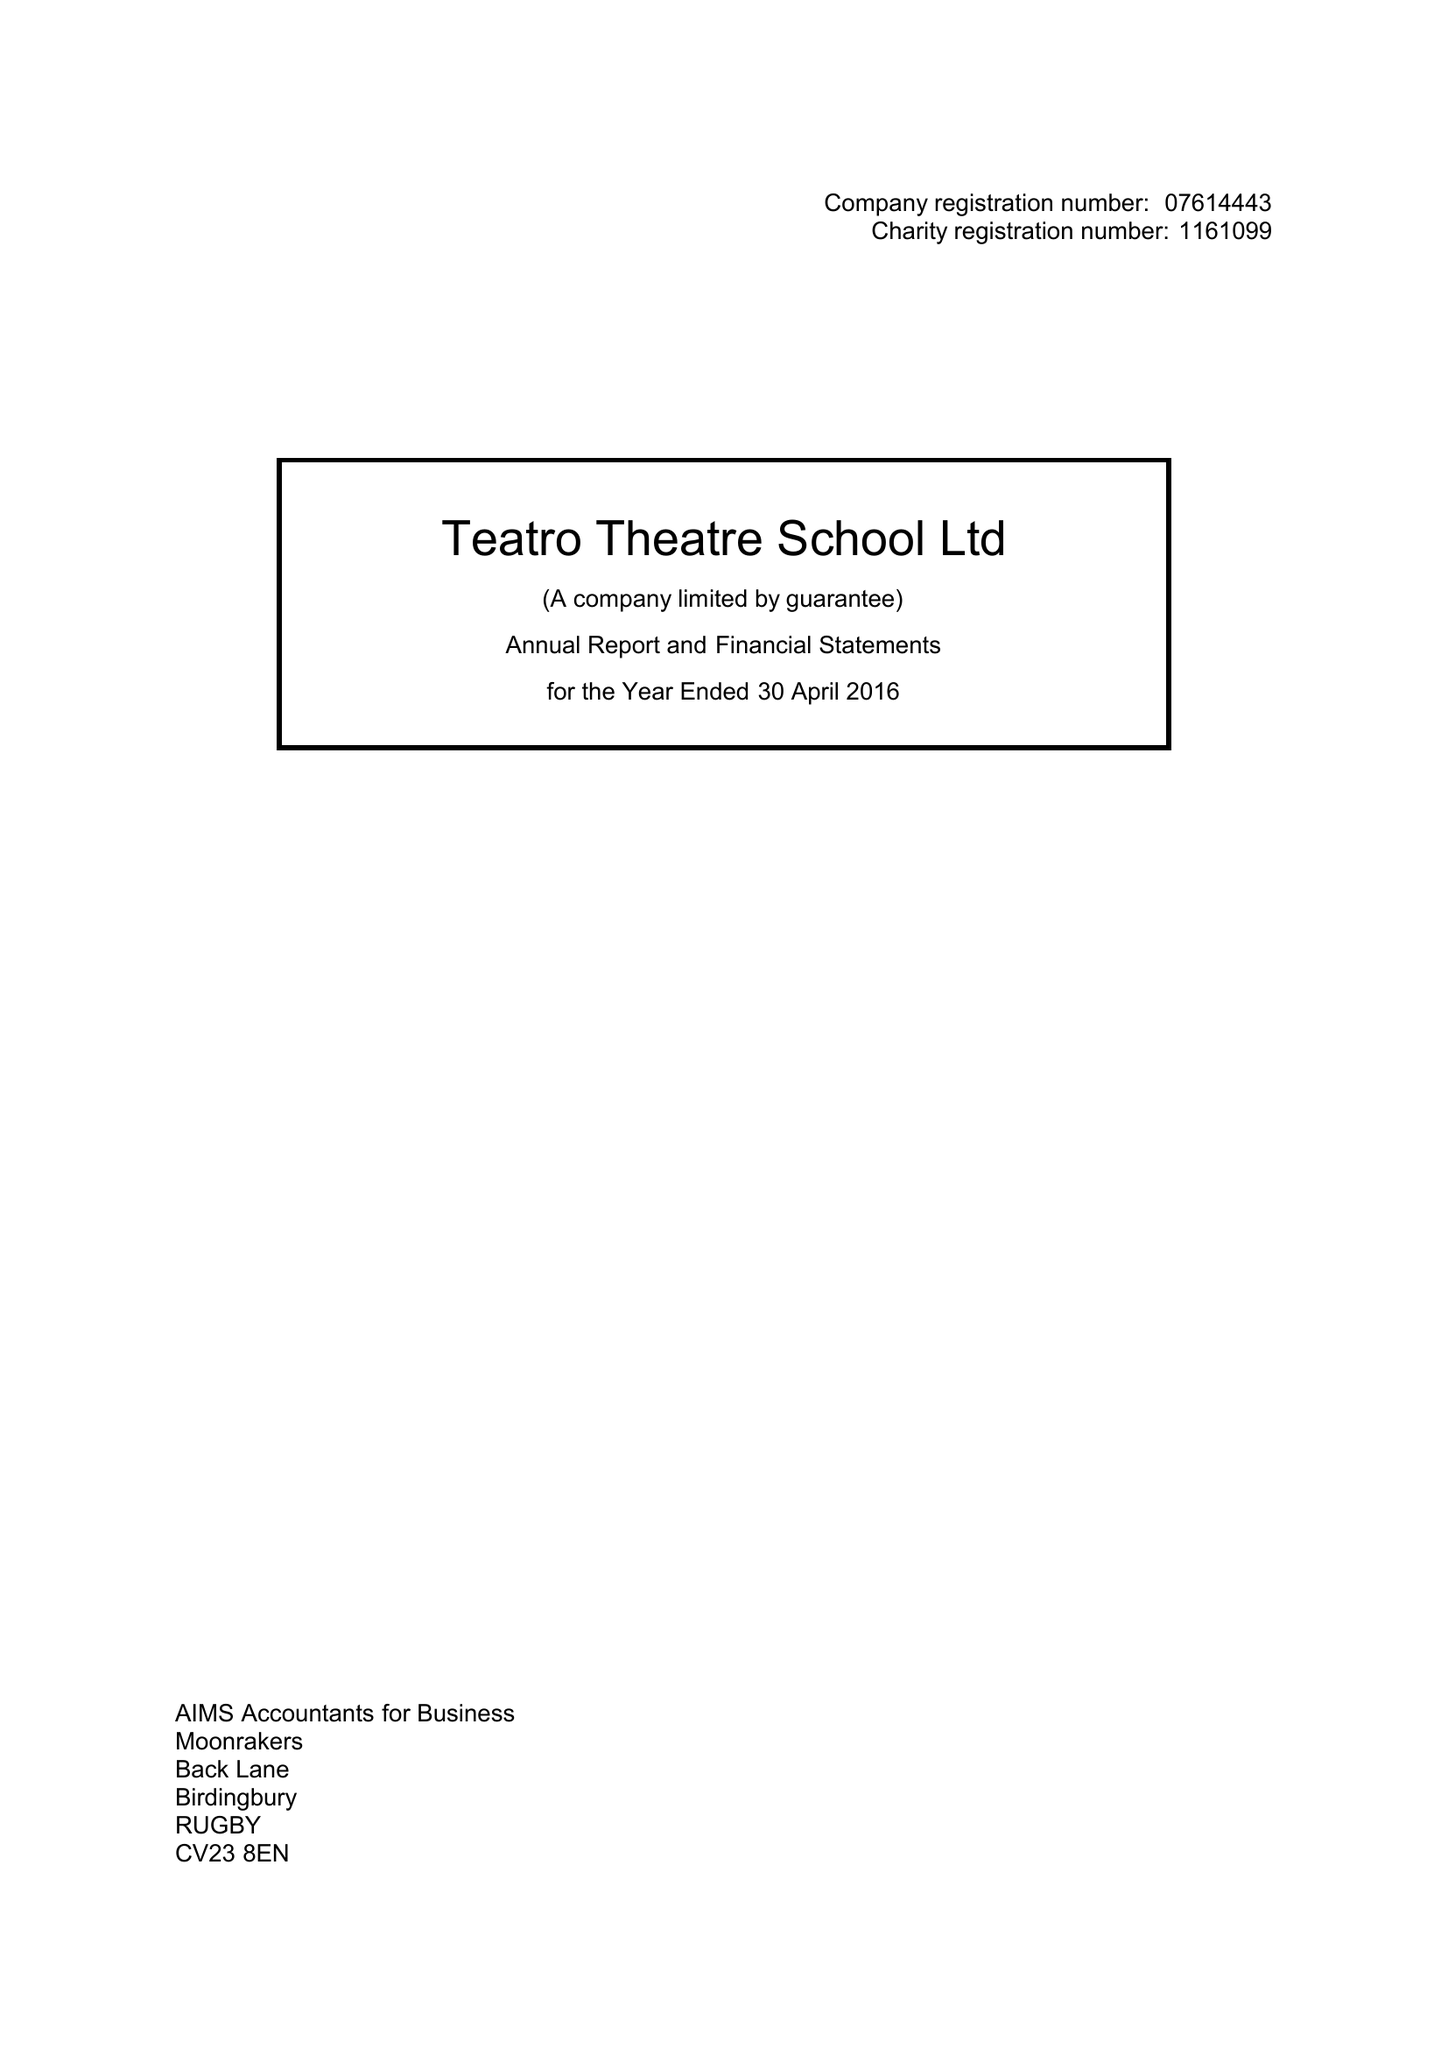What is the value for the charity_name?
Answer the question using a single word or phrase. Teatro Theatre School Ltd. 